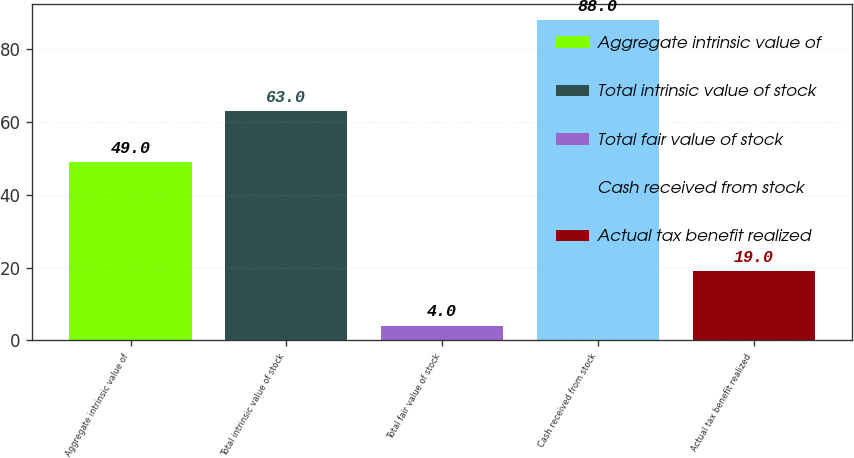Convert chart. <chart><loc_0><loc_0><loc_500><loc_500><bar_chart><fcel>Aggregate intrinsic value of<fcel>Total intrinsic value of stock<fcel>Total fair value of stock<fcel>Cash received from stock<fcel>Actual tax benefit realized<nl><fcel>49<fcel>63<fcel>4<fcel>88<fcel>19<nl></chart> 